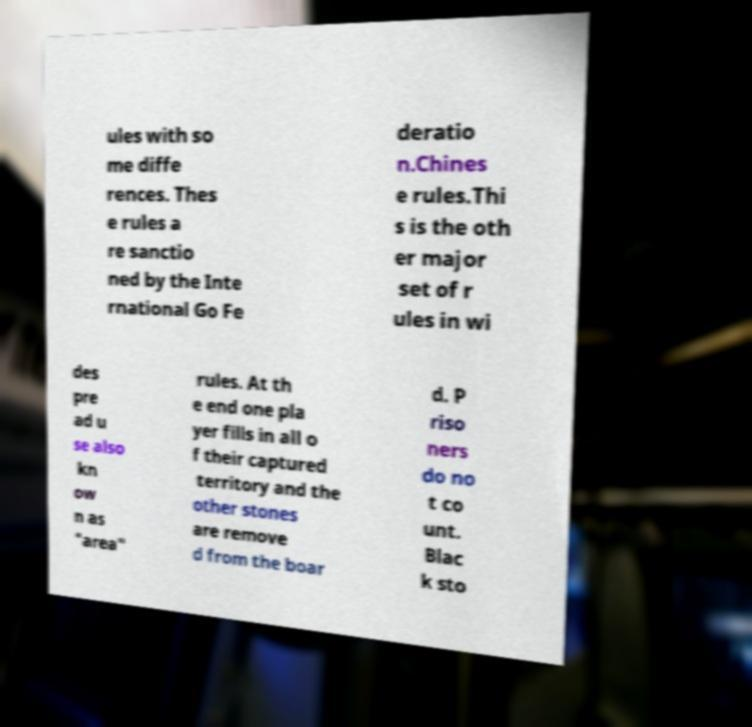For documentation purposes, I need the text within this image transcribed. Could you provide that? ules with so me diffe rences. Thes e rules a re sanctio ned by the Inte rnational Go Fe deratio n.Chines e rules.Thi s is the oth er major set of r ules in wi des pre ad u se also kn ow n as "area" rules. At th e end one pla yer fills in all o f their captured territory and the other stones are remove d from the boar d. P riso ners do no t co unt. Blac k sto 